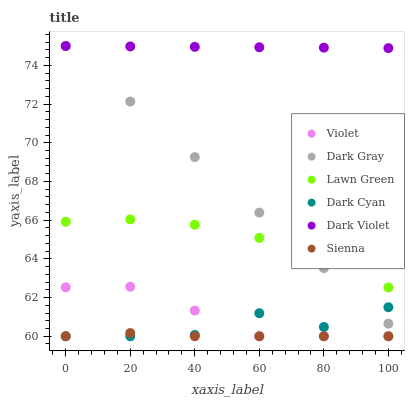Does Sienna have the minimum area under the curve?
Answer yes or no. Yes. Does Dark Violet have the maximum area under the curve?
Answer yes or no. Yes. Does Dark Gray have the minimum area under the curve?
Answer yes or no. No. Does Dark Gray have the maximum area under the curve?
Answer yes or no. No. Is Dark Violet the smoothest?
Answer yes or no. Yes. Is Dark Cyan the roughest?
Answer yes or no. Yes. Is Dark Gray the smoothest?
Answer yes or no. No. Is Dark Gray the roughest?
Answer yes or no. No. Does Sienna have the lowest value?
Answer yes or no. Yes. Does Dark Gray have the lowest value?
Answer yes or no. No. Does Dark Gray have the highest value?
Answer yes or no. Yes. Does Sienna have the highest value?
Answer yes or no. No. Is Dark Cyan less than Lawn Green?
Answer yes or no. Yes. Is Lawn Green greater than Sienna?
Answer yes or no. Yes. Does Sienna intersect Dark Cyan?
Answer yes or no. Yes. Is Sienna less than Dark Cyan?
Answer yes or no. No. Is Sienna greater than Dark Cyan?
Answer yes or no. No. Does Dark Cyan intersect Lawn Green?
Answer yes or no. No. 